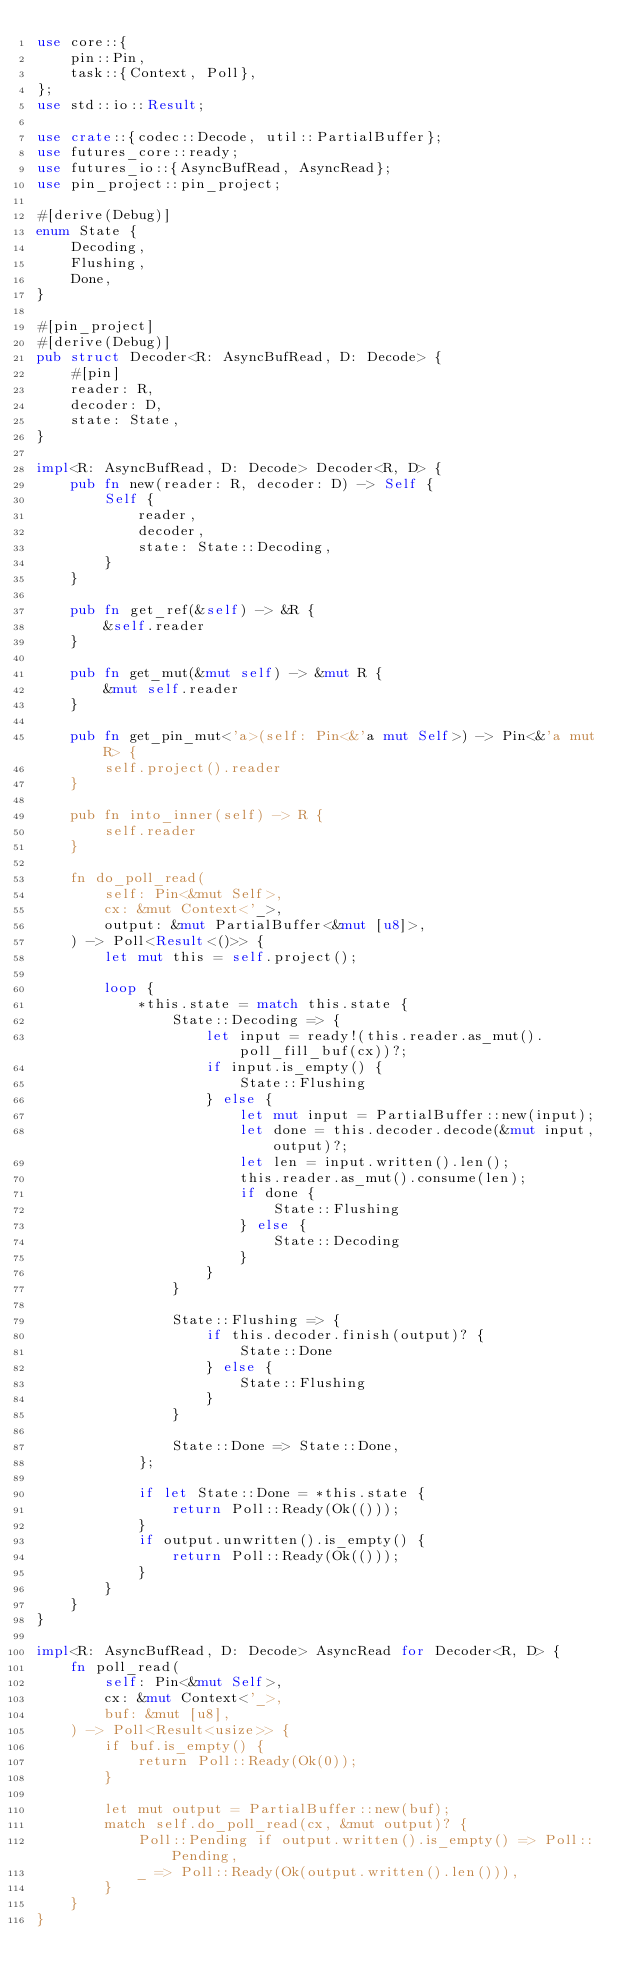Convert code to text. <code><loc_0><loc_0><loc_500><loc_500><_Rust_>use core::{
    pin::Pin,
    task::{Context, Poll},
};
use std::io::Result;

use crate::{codec::Decode, util::PartialBuffer};
use futures_core::ready;
use futures_io::{AsyncBufRead, AsyncRead};
use pin_project::pin_project;

#[derive(Debug)]
enum State {
    Decoding,
    Flushing,
    Done,
}

#[pin_project]
#[derive(Debug)]
pub struct Decoder<R: AsyncBufRead, D: Decode> {
    #[pin]
    reader: R,
    decoder: D,
    state: State,
}

impl<R: AsyncBufRead, D: Decode> Decoder<R, D> {
    pub fn new(reader: R, decoder: D) -> Self {
        Self {
            reader,
            decoder,
            state: State::Decoding,
        }
    }

    pub fn get_ref(&self) -> &R {
        &self.reader
    }

    pub fn get_mut(&mut self) -> &mut R {
        &mut self.reader
    }

    pub fn get_pin_mut<'a>(self: Pin<&'a mut Self>) -> Pin<&'a mut R> {
        self.project().reader
    }

    pub fn into_inner(self) -> R {
        self.reader
    }

    fn do_poll_read(
        self: Pin<&mut Self>,
        cx: &mut Context<'_>,
        output: &mut PartialBuffer<&mut [u8]>,
    ) -> Poll<Result<()>> {
        let mut this = self.project();

        loop {
            *this.state = match this.state {
                State::Decoding => {
                    let input = ready!(this.reader.as_mut().poll_fill_buf(cx))?;
                    if input.is_empty() {
                        State::Flushing
                    } else {
                        let mut input = PartialBuffer::new(input);
                        let done = this.decoder.decode(&mut input, output)?;
                        let len = input.written().len();
                        this.reader.as_mut().consume(len);
                        if done {
                            State::Flushing
                        } else {
                            State::Decoding
                        }
                    }
                }

                State::Flushing => {
                    if this.decoder.finish(output)? {
                        State::Done
                    } else {
                        State::Flushing
                    }
                }

                State::Done => State::Done,
            };

            if let State::Done = *this.state {
                return Poll::Ready(Ok(()));
            }
            if output.unwritten().is_empty() {
                return Poll::Ready(Ok(()));
            }
        }
    }
}

impl<R: AsyncBufRead, D: Decode> AsyncRead for Decoder<R, D> {
    fn poll_read(
        self: Pin<&mut Self>,
        cx: &mut Context<'_>,
        buf: &mut [u8],
    ) -> Poll<Result<usize>> {
        if buf.is_empty() {
            return Poll::Ready(Ok(0));
        }

        let mut output = PartialBuffer::new(buf);
        match self.do_poll_read(cx, &mut output)? {
            Poll::Pending if output.written().is_empty() => Poll::Pending,
            _ => Poll::Ready(Ok(output.written().len())),
        }
    }
}
</code> 